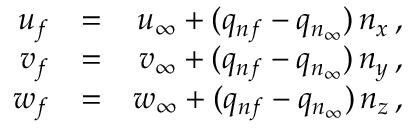<formula> <loc_0><loc_0><loc_500><loc_500>\begin{array} { r l r } { { u _ { f } } } & { = } & { { u _ { \infty } + ( q _ { n f } - q _ { n _ { \infty } } ) \, n _ { x } \, , } } \\ { { v _ { f } } } & { = } & { { v _ { \infty } + ( q _ { n f } - q _ { n _ { \infty } } ) \, n _ { y } \, , } } \\ { { w _ { f } } } & { = } & { { w _ { \infty } + ( q _ { n f } - q _ { n _ { \infty } } ) \, n _ { z } \, , } } \end{array}</formula> 